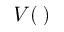Convert formula to latex. <formula><loc_0><loc_0><loc_500><loc_500>V ( \, )</formula> 